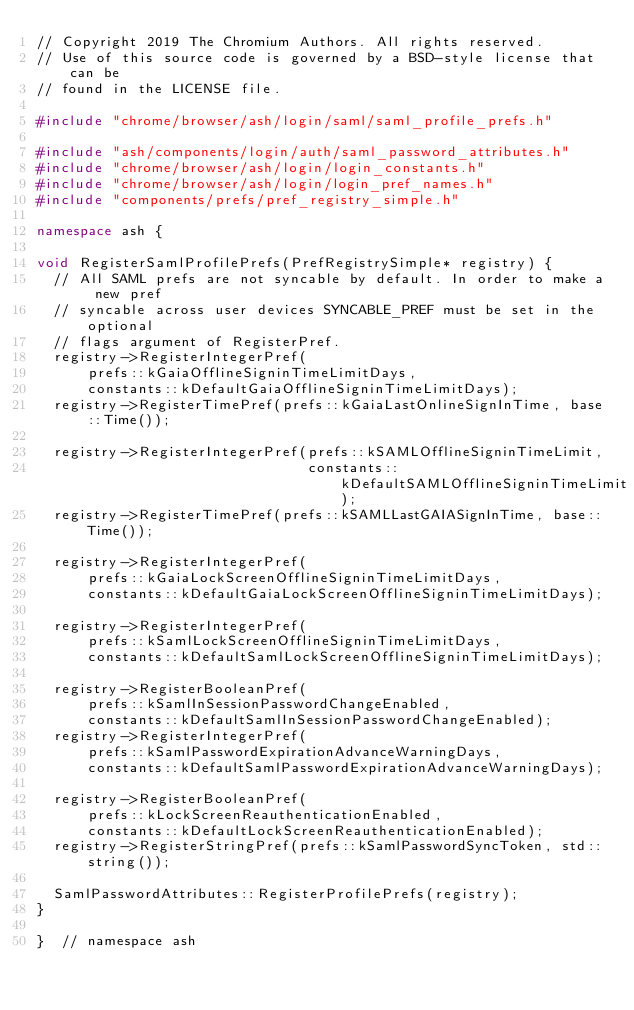Convert code to text. <code><loc_0><loc_0><loc_500><loc_500><_C++_>// Copyright 2019 The Chromium Authors. All rights reserved.
// Use of this source code is governed by a BSD-style license that can be
// found in the LICENSE file.

#include "chrome/browser/ash/login/saml/saml_profile_prefs.h"

#include "ash/components/login/auth/saml_password_attributes.h"
#include "chrome/browser/ash/login/login_constants.h"
#include "chrome/browser/ash/login/login_pref_names.h"
#include "components/prefs/pref_registry_simple.h"

namespace ash {

void RegisterSamlProfilePrefs(PrefRegistrySimple* registry) {
  // All SAML prefs are not syncable by default. In order to make a new pref
  // syncable across user devices SYNCABLE_PREF must be set in the optional
  // flags argument of RegisterPref.
  registry->RegisterIntegerPref(
      prefs::kGaiaOfflineSigninTimeLimitDays,
      constants::kDefaultGaiaOfflineSigninTimeLimitDays);
  registry->RegisterTimePref(prefs::kGaiaLastOnlineSignInTime, base::Time());

  registry->RegisterIntegerPref(prefs::kSAMLOfflineSigninTimeLimit,
                                constants::kDefaultSAMLOfflineSigninTimeLimit);
  registry->RegisterTimePref(prefs::kSAMLLastGAIASignInTime, base::Time());

  registry->RegisterIntegerPref(
      prefs::kGaiaLockScreenOfflineSigninTimeLimitDays,
      constants::kDefaultGaiaLockScreenOfflineSigninTimeLimitDays);

  registry->RegisterIntegerPref(
      prefs::kSamlLockScreenOfflineSigninTimeLimitDays,
      constants::kDefaultSamlLockScreenOfflineSigninTimeLimitDays);

  registry->RegisterBooleanPref(
      prefs::kSamlInSessionPasswordChangeEnabled,
      constants::kDefaultSamlInSessionPasswordChangeEnabled);
  registry->RegisterIntegerPref(
      prefs::kSamlPasswordExpirationAdvanceWarningDays,
      constants::kDefaultSamlPasswordExpirationAdvanceWarningDays);

  registry->RegisterBooleanPref(
      prefs::kLockScreenReauthenticationEnabled,
      constants::kDefaultLockScreenReauthenticationEnabled);
  registry->RegisterStringPref(prefs::kSamlPasswordSyncToken, std::string());

  SamlPasswordAttributes::RegisterProfilePrefs(registry);
}

}  // namespace ash
</code> 